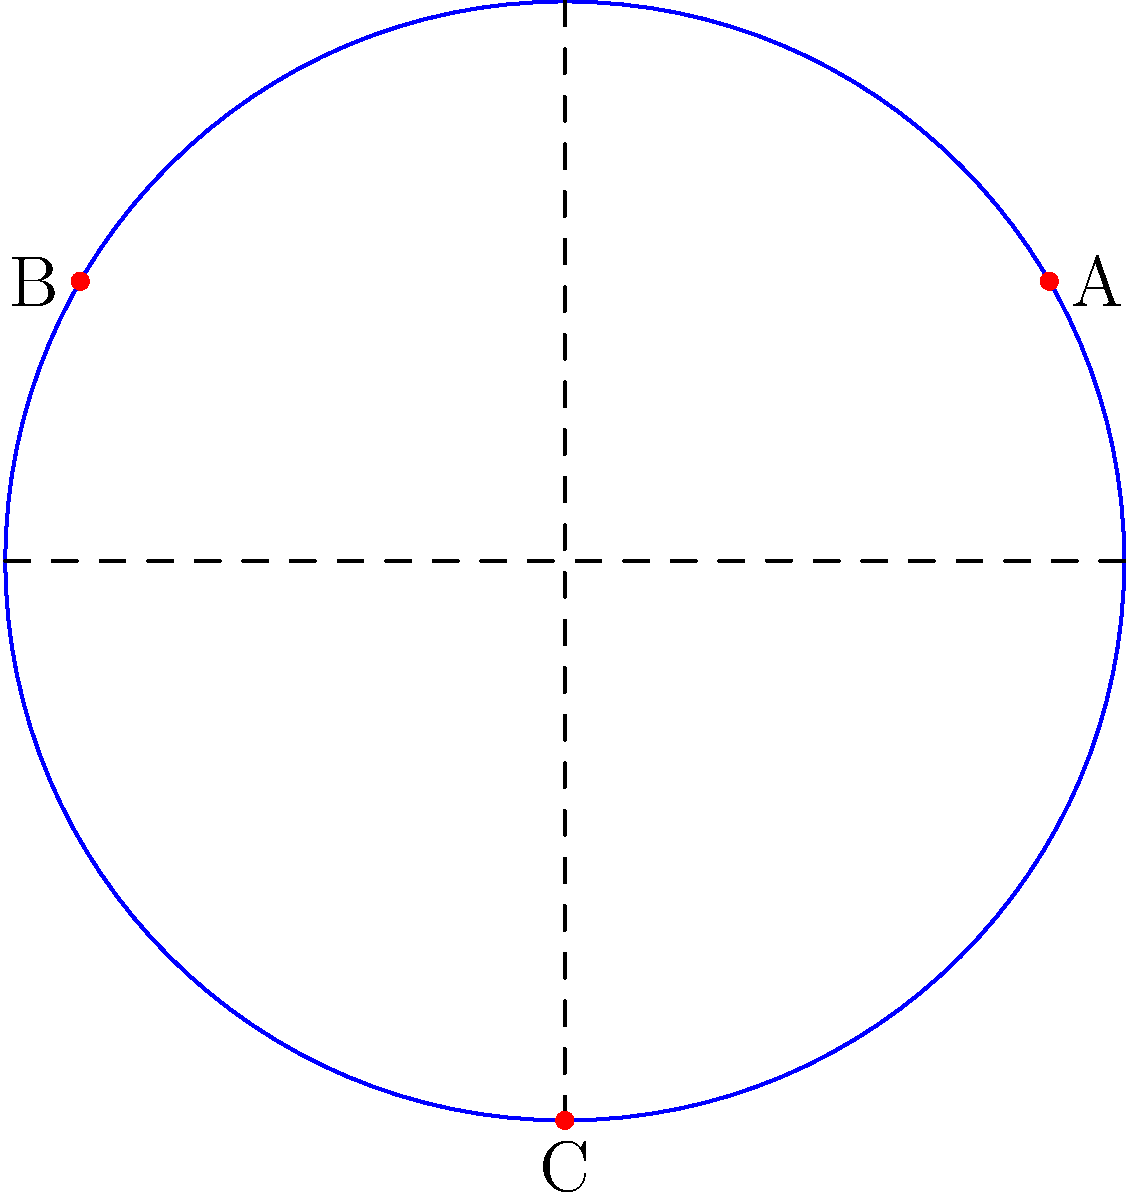In a circular room with a radius of 10 meters, three motion detectors need to be placed for optimal coverage. The detectors are positioned at points A, B, and C, as shown in the diagram. If the polar coordinates of point A are $(10, \frac{\pi}{6})$, what are the polar coordinates of points B and C? To solve this problem, we need to analyze the symmetry of the detector placement and use our knowledge of polar coordinates. Let's approach this step-by-step:

1. We're given that point A has polar coordinates $(10, \frac{\pi}{6})$. This means it's 10 meters from the center at an angle of $\frac{\pi}{6}$ radians (or 30 degrees) from the positive x-axis.

2. Looking at the diagram, we can see that the three detectors form an equilateral triangle inscribed in the circle. This means they are spaced 120° (or $\frac{2\pi}{3}$ radians) apart.

3. To find point B, we need to add $\frac{2\pi}{3}$ to the angle of point A:
   $\frac{\pi}{6} + \frac{2\pi}{3} = \frac{\pi}{6} + \frac{4\pi}{6} = \frac{5\pi}{6}$

4. The radius remains the same, so the polar coordinates of point B are $(10, \frac{5\pi}{6})$.

5. For point C, we add another $\frac{2\pi}{3}$ to the angle of point B:
   $\frac{5\pi}{6} + \frac{2\pi}{3} = \frac{5\pi}{6} + \frac{4\pi}{6} = \frac{9\pi}{6} = \frac{3\pi}{2}$

6. Therefore, the polar coordinates of point C are $(10, \frac{3\pi}{2})$.
Answer: B: $(10, \frac{5\pi}{6})$, C: $(10, \frac{3\pi}{2})$ 